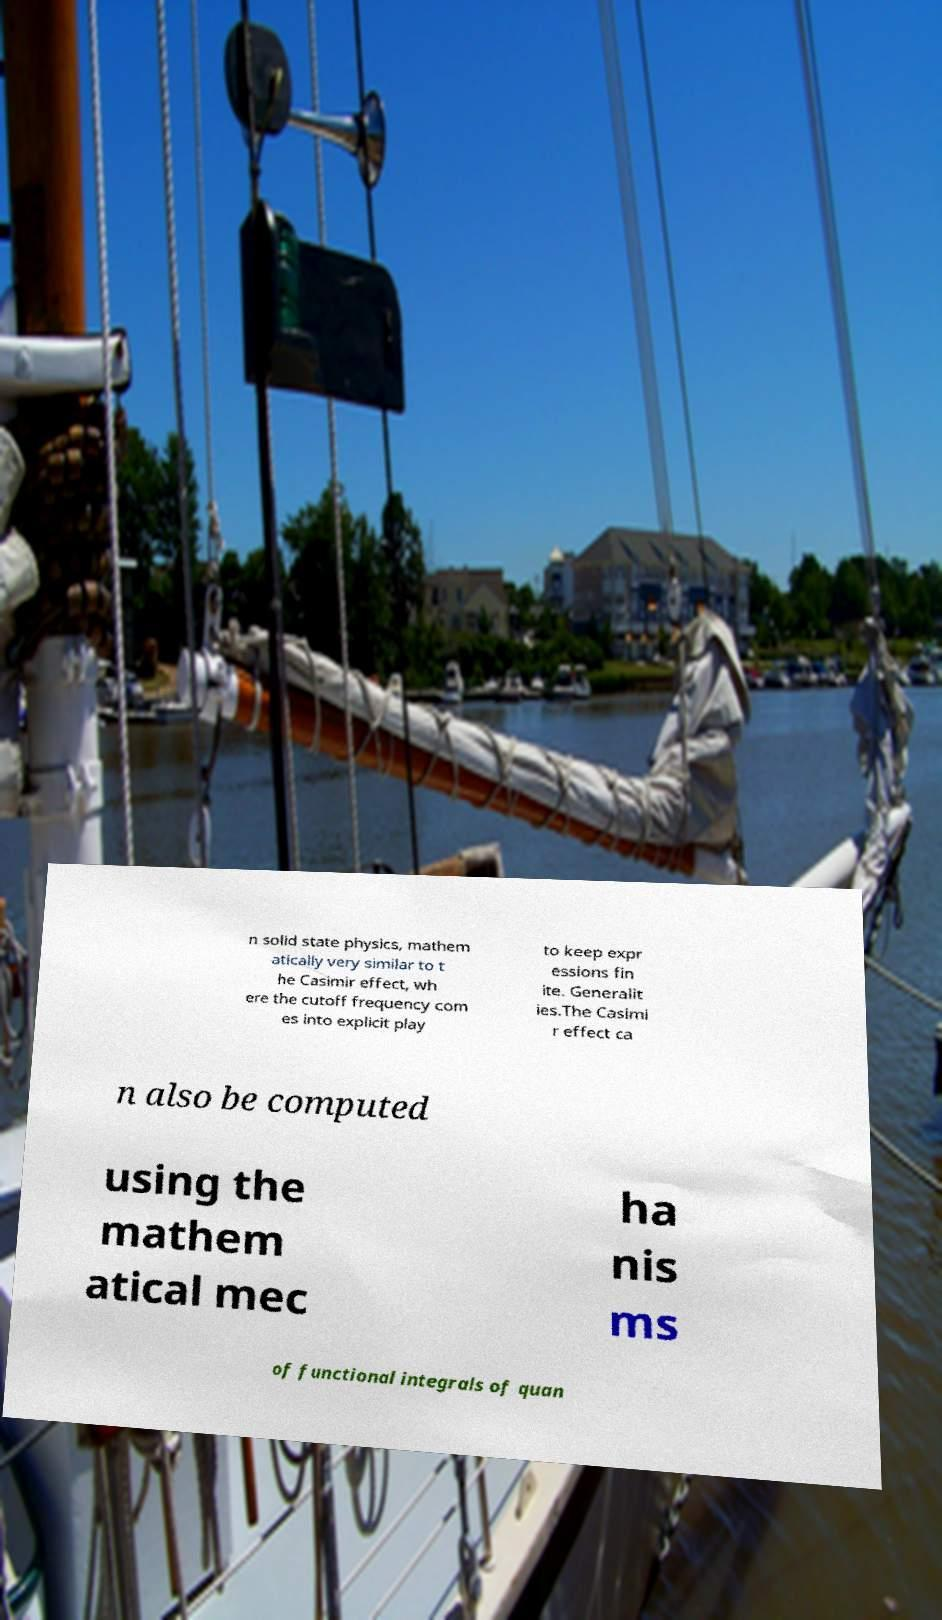I need the written content from this picture converted into text. Can you do that? n solid state physics, mathem atically very similar to t he Casimir effect, wh ere the cutoff frequency com es into explicit play to keep expr essions fin ite. Generalit ies.The Casimi r effect ca n also be computed using the mathem atical mec ha nis ms of functional integrals of quan 